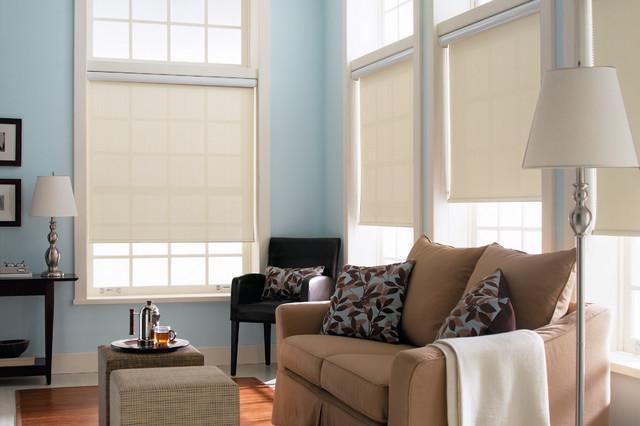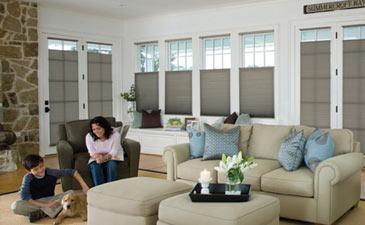The first image is the image on the left, the second image is the image on the right. Analyze the images presented: Is the assertion "All of the blinds in each image are open at equal lengths to the others in the same image." valid? Answer yes or no. No. 